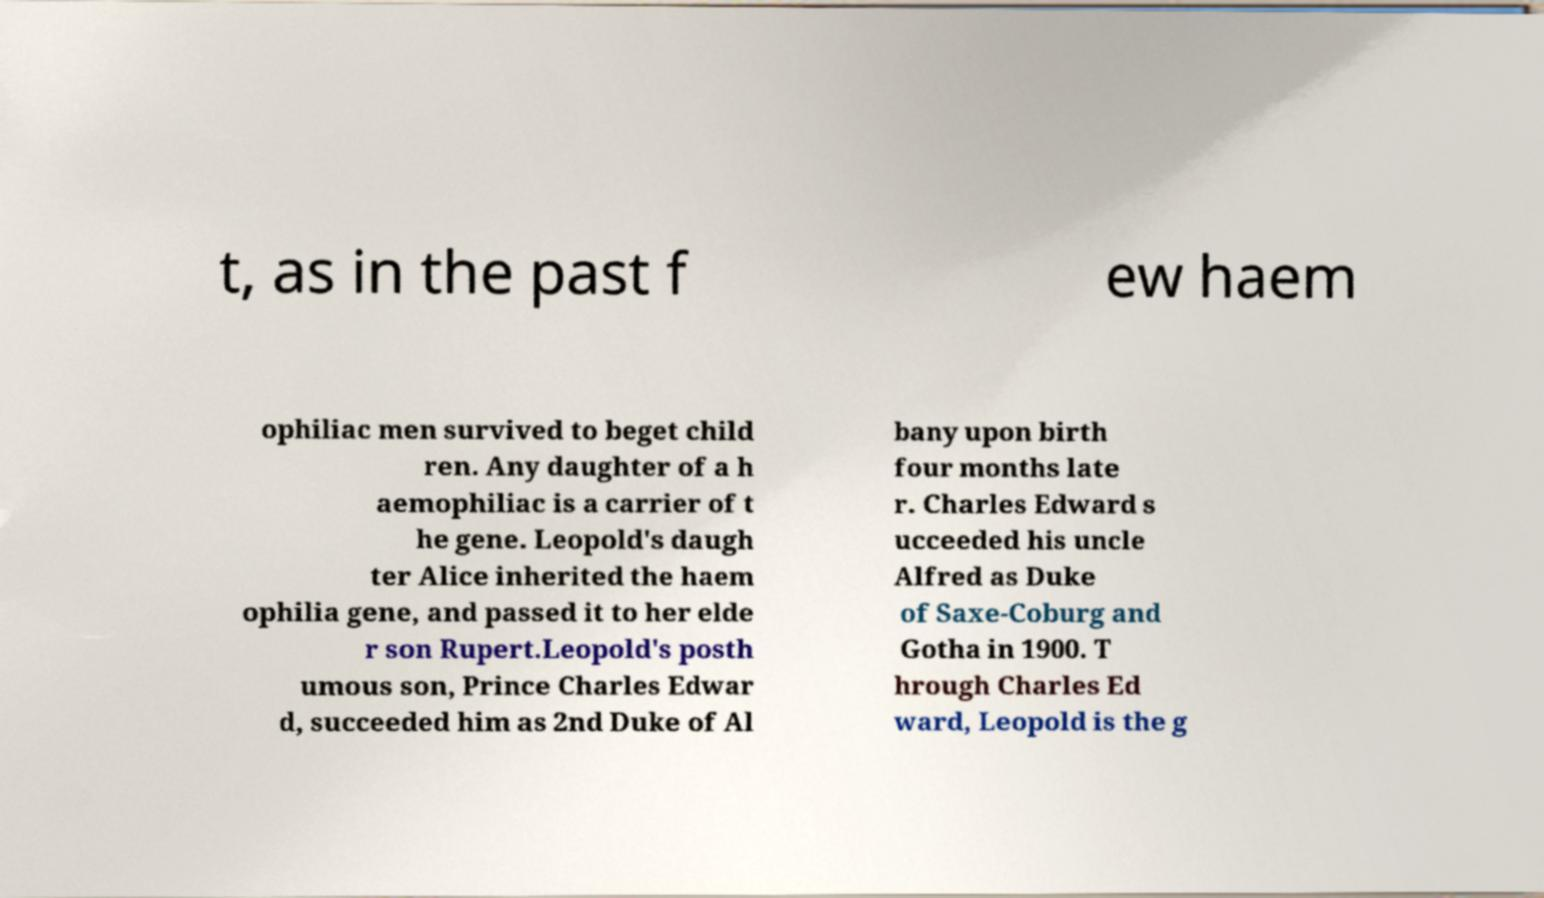Can you read and provide the text displayed in the image?This photo seems to have some interesting text. Can you extract and type it out for me? t, as in the past f ew haem ophiliac men survived to beget child ren. Any daughter of a h aemophiliac is a carrier of t he gene. Leopold's daugh ter Alice inherited the haem ophilia gene, and passed it to her elde r son Rupert.Leopold's posth umous son, Prince Charles Edwar d, succeeded him as 2nd Duke of Al bany upon birth four months late r. Charles Edward s ucceeded his uncle Alfred as Duke of Saxe-Coburg and Gotha in 1900. T hrough Charles Ed ward, Leopold is the g 